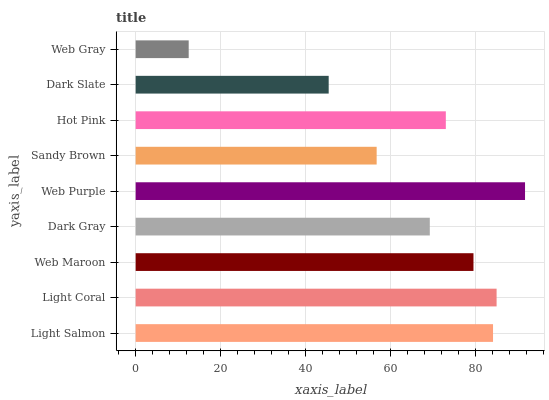Is Web Gray the minimum?
Answer yes or no. Yes. Is Web Purple the maximum?
Answer yes or no. Yes. Is Light Coral the minimum?
Answer yes or no. No. Is Light Coral the maximum?
Answer yes or no. No. Is Light Coral greater than Light Salmon?
Answer yes or no. Yes. Is Light Salmon less than Light Coral?
Answer yes or no. Yes. Is Light Salmon greater than Light Coral?
Answer yes or no. No. Is Light Coral less than Light Salmon?
Answer yes or no. No. Is Hot Pink the high median?
Answer yes or no. Yes. Is Hot Pink the low median?
Answer yes or no. Yes. Is Sandy Brown the high median?
Answer yes or no. No. Is Dark Slate the low median?
Answer yes or no. No. 